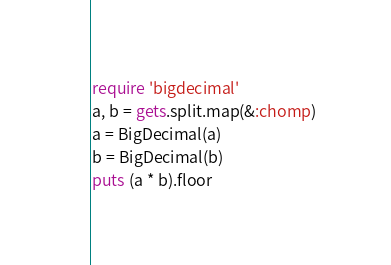Convert code to text. <code><loc_0><loc_0><loc_500><loc_500><_Ruby_>require 'bigdecimal'
a, b = gets.split.map(&:chomp)
a = BigDecimal(a)
b = BigDecimal(b)
puts (a * b).floor</code> 